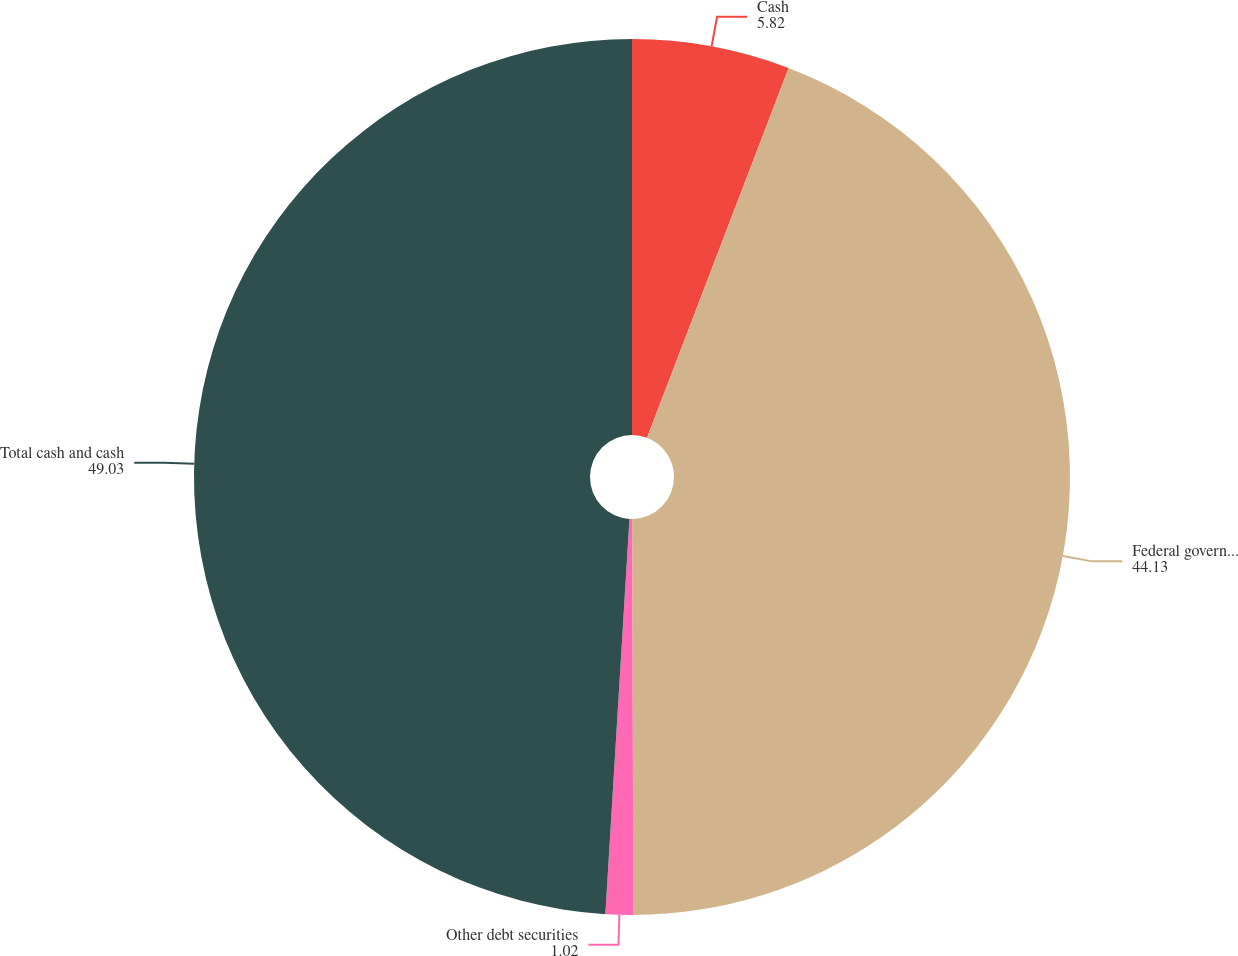Convert chart to OTSL. <chart><loc_0><loc_0><loc_500><loc_500><pie_chart><fcel>Cash<fcel>Federal government obligations<fcel>Other debt securities<fcel>Total cash and cash<nl><fcel>5.82%<fcel>44.13%<fcel>1.02%<fcel>49.03%<nl></chart> 